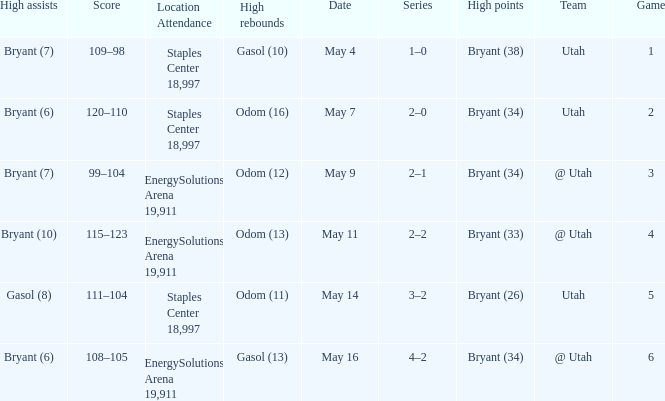What is the Series with a High rebounds with gasol (10)? 1–0. 